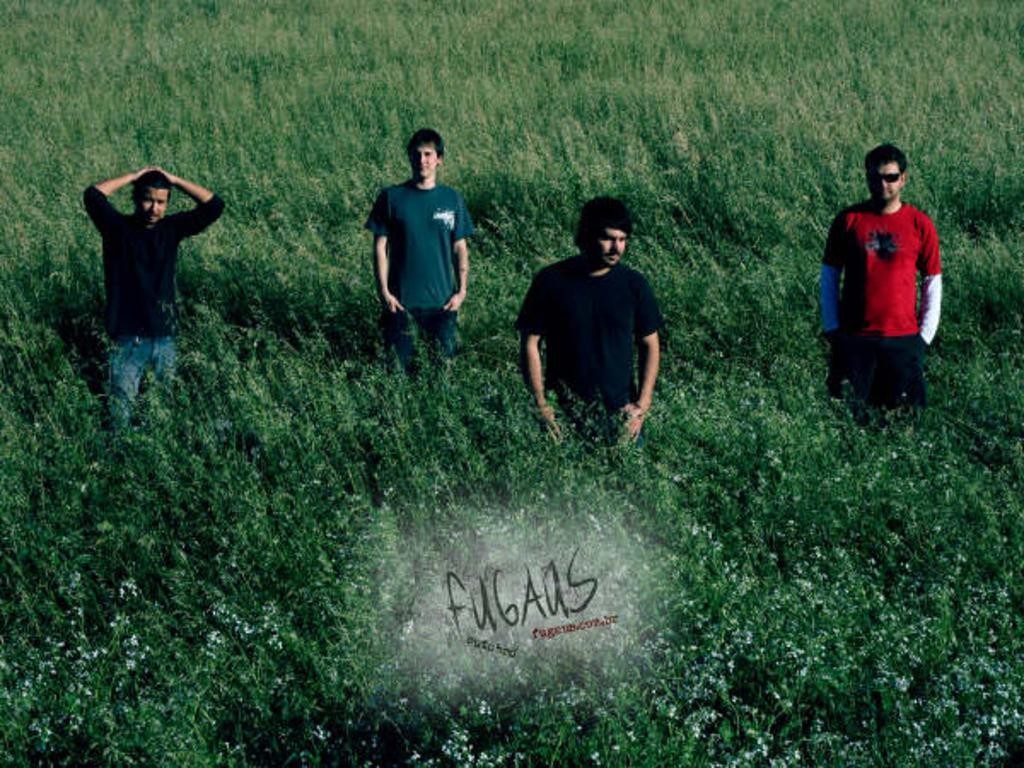How many people are in the field in the image? There are four persons standing in the field. What else can be seen in the field besides the people? There are trees and flowers in the field. Is there any text present in the image? Yes, there is some text on the image. Can you tell me where the lake is located in the image? There is no lake present in the image; it features a field with trees, flowers, and four persons. What type of cart is being used by the persons in the image? There is no cart present in the image; the four persons are standing in the field. 